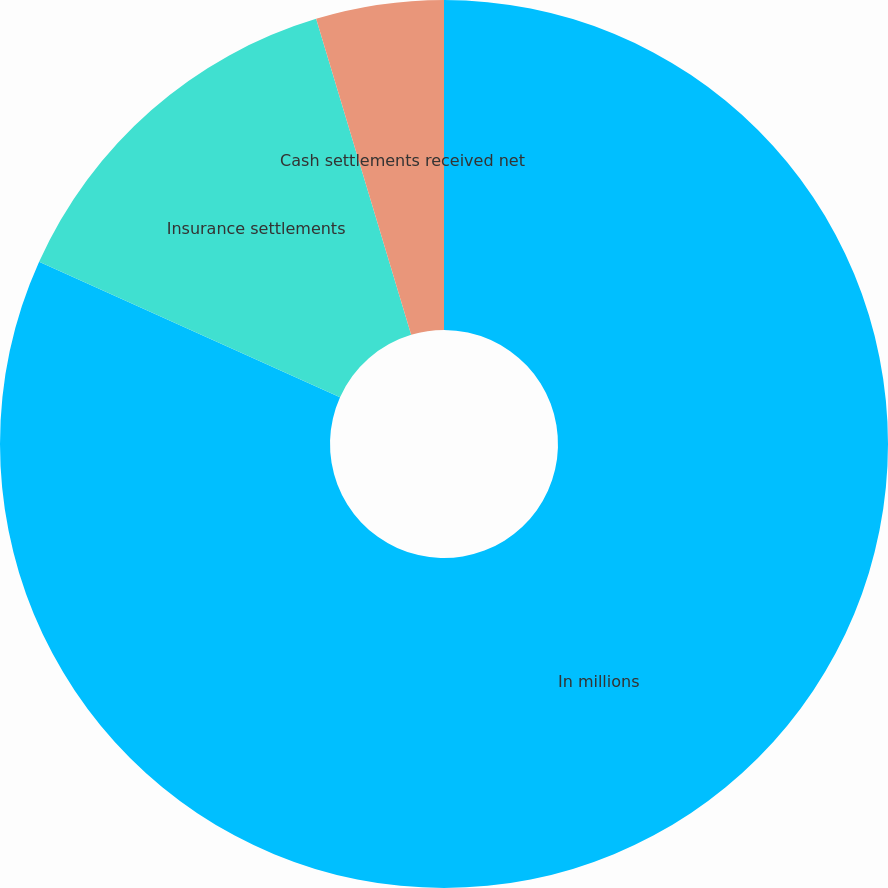Convert chart. <chart><loc_0><loc_0><loc_500><loc_500><pie_chart><fcel>In millions<fcel>Insurance settlements<fcel>Cash settlements received net<nl><fcel>81.74%<fcel>13.62%<fcel>4.65%<nl></chart> 